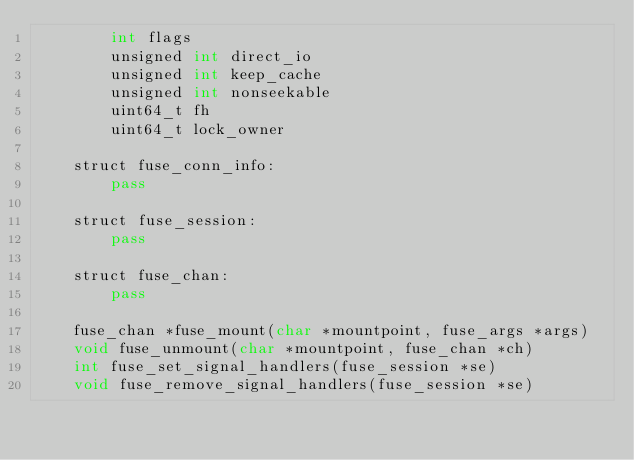Convert code to text. <code><loc_0><loc_0><loc_500><loc_500><_Cython_>        int flags
        unsigned int direct_io
        unsigned int keep_cache
        unsigned int nonseekable
        uint64_t fh
        uint64_t lock_owner

    struct fuse_conn_info:
        pass

    struct fuse_session:
        pass

    struct fuse_chan:
        pass

    fuse_chan *fuse_mount(char *mountpoint, fuse_args *args)
    void fuse_unmount(char *mountpoint, fuse_chan *ch)
    int fuse_set_signal_handlers(fuse_session *se)
    void fuse_remove_signal_handlers(fuse_session *se)
</code> 